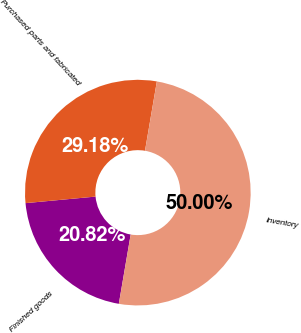Convert chart. <chart><loc_0><loc_0><loc_500><loc_500><pie_chart><fcel>Finished goods<fcel>Purchased parts and fabricated<fcel>Inventory<nl><fcel>20.82%<fcel>29.18%<fcel>50.0%<nl></chart> 